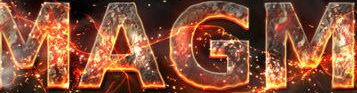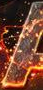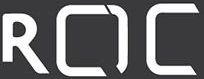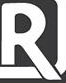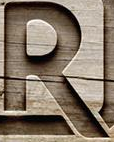Read the text content from these images in order, separated by a semicolon. MAGM; #; ROC; R; R 